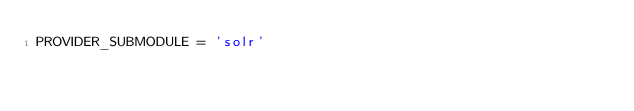<code> <loc_0><loc_0><loc_500><loc_500><_Python_>PROVIDER_SUBMODULE = 'solr'
</code> 